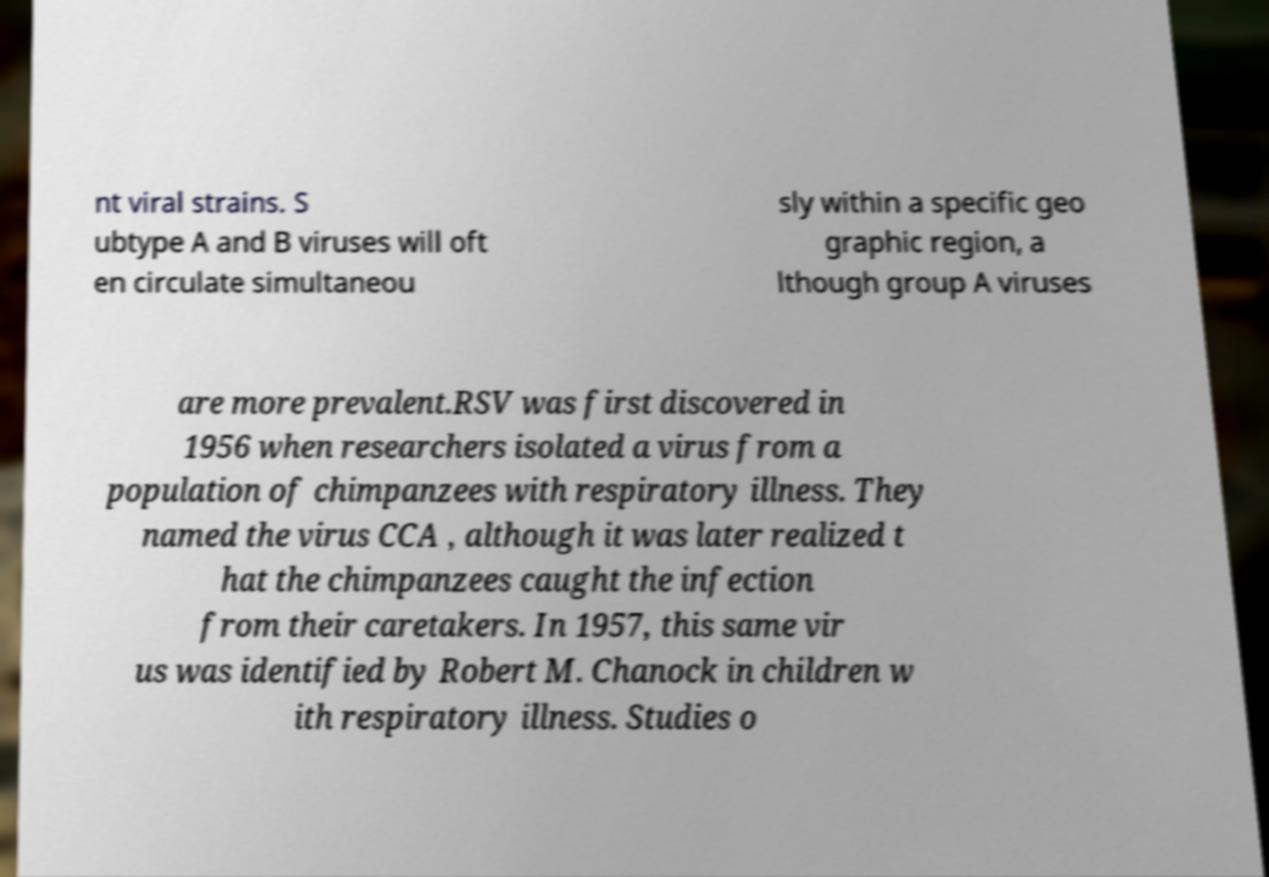Could you assist in decoding the text presented in this image and type it out clearly? nt viral strains. S ubtype A and B viruses will oft en circulate simultaneou sly within a specific geo graphic region, a lthough group A viruses are more prevalent.RSV was first discovered in 1956 when researchers isolated a virus from a population of chimpanzees with respiratory illness. They named the virus CCA , although it was later realized t hat the chimpanzees caught the infection from their caretakers. In 1957, this same vir us was identified by Robert M. Chanock in children w ith respiratory illness. Studies o 